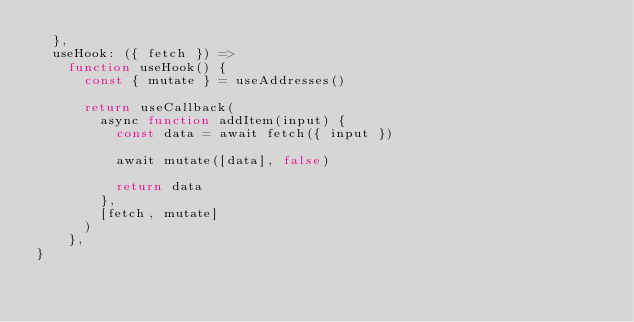Convert code to text. <code><loc_0><loc_0><loc_500><loc_500><_TypeScript_>  },
  useHook: ({ fetch }) =>
    function useHook() {
      const { mutate } = useAddresses()

      return useCallback(
        async function addItem(input) {
          const data = await fetch({ input })

          await mutate([data], false)

          return data
        },
        [fetch, mutate]
      )
    },
}
</code> 